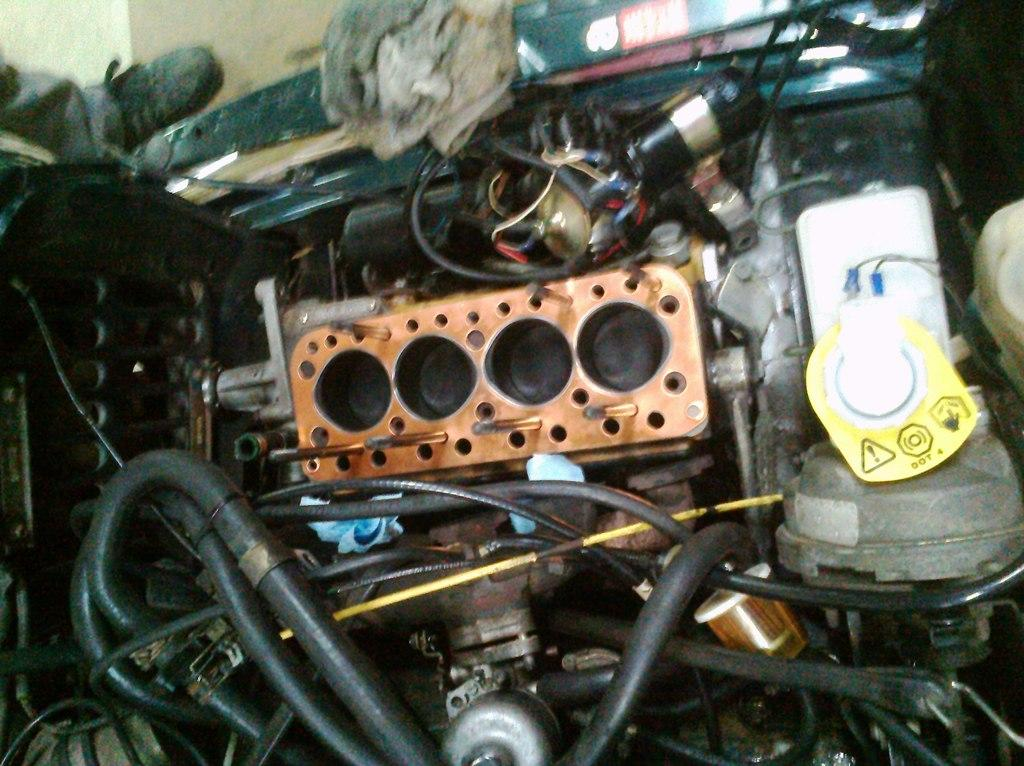What type of objects can be seen in the image? The image contains cables and various instruments. Can you describe the person's leg visible in the image? There is a person's leg visible in the top left corner of the image. What part of the room can be seen in the image? The floor is visible in the image. What direction is the house facing in the image? There is no house present in the image. 